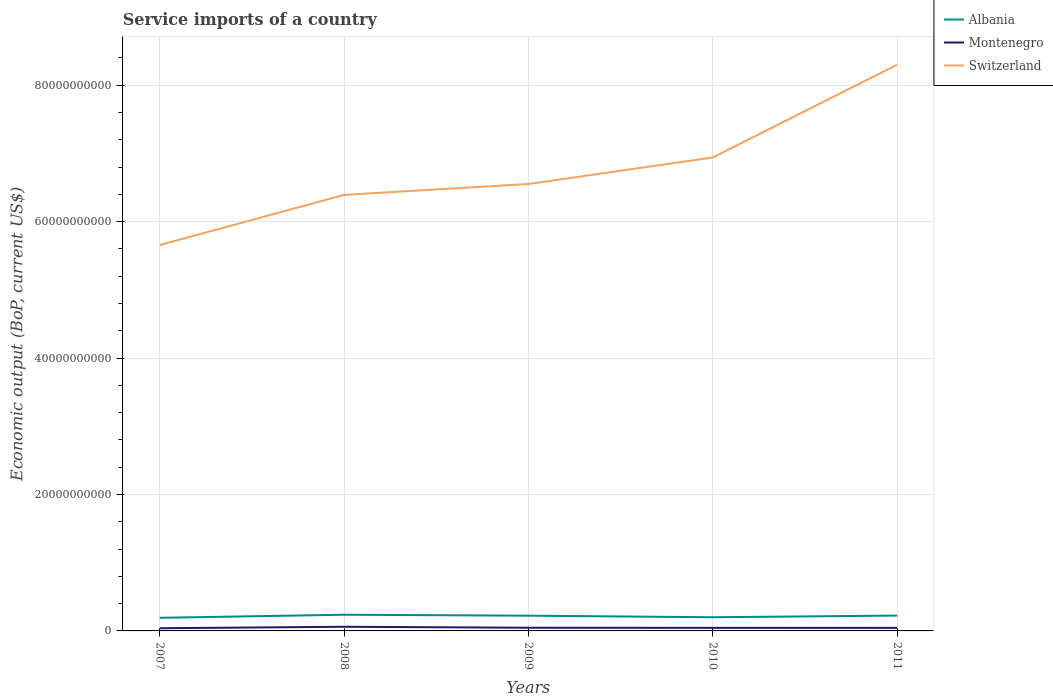Is the number of lines equal to the number of legend labels?
Make the answer very short. Yes. Across all years, what is the maximum service imports in Switzerland?
Your response must be concise. 5.66e+1. In which year was the service imports in Switzerland maximum?
Provide a short and direct response. 2007. What is the total service imports in Albania in the graph?
Keep it short and to the point. 2.26e+08. What is the difference between the highest and the second highest service imports in Albania?
Your answer should be compact. 4.48e+08. Is the service imports in Montenegro strictly greater than the service imports in Switzerland over the years?
Give a very brief answer. Yes. How many lines are there?
Ensure brevity in your answer.  3. What is the difference between two consecutive major ticks on the Y-axis?
Provide a short and direct response. 2.00e+1. Does the graph contain any zero values?
Provide a succinct answer. No. Where does the legend appear in the graph?
Make the answer very short. Top right. How many legend labels are there?
Make the answer very short. 3. What is the title of the graph?
Ensure brevity in your answer.  Service imports of a country. Does "Azerbaijan" appear as one of the legend labels in the graph?
Provide a short and direct response. No. What is the label or title of the X-axis?
Your response must be concise. Years. What is the label or title of the Y-axis?
Provide a short and direct response. Economic output (BoP, current US$). What is the Economic output (BoP, current US$) in Albania in 2007?
Your answer should be very brief. 1.92e+09. What is the Economic output (BoP, current US$) of Montenegro in 2007?
Ensure brevity in your answer.  3.94e+08. What is the Economic output (BoP, current US$) of Switzerland in 2007?
Provide a succinct answer. 5.66e+1. What is the Economic output (BoP, current US$) in Albania in 2008?
Your answer should be compact. 2.37e+09. What is the Economic output (BoP, current US$) in Montenegro in 2008?
Offer a very short reply. 6.09e+08. What is the Economic output (BoP, current US$) of Switzerland in 2008?
Provide a succinct answer. 6.39e+1. What is the Economic output (BoP, current US$) of Albania in 2009?
Keep it short and to the point. 2.23e+09. What is the Economic output (BoP, current US$) of Montenegro in 2009?
Make the answer very short. 4.67e+08. What is the Economic output (BoP, current US$) of Switzerland in 2009?
Your answer should be compact. 6.55e+1. What is the Economic output (BoP, current US$) in Albania in 2010?
Your response must be concise. 2.01e+09. What is the Economic output (BoP, current US$) in Montenegro in 2010?
Offer a very short reply. 4.51e+08. What is the Economic output (BoP, current US$) in Switzerland in 2010?
Ensure brevity in your answer.  6.94e+1. What is the Economic output (BoP, current US$) of Albania in 2011?
Provide a succinct answer. 2.25e+09. What is the Economic output (BoP, current US$) of Montenegro in 2011?
Offer a terse response. 4.48e+08. What is the Economic output (BoP, current US$) in Switzerland in 2011?
Give a very brief answer. 8.30e+1. Across all years, what is the maximum Economic output (BoP, current US$) in Albania?
Your response must be concise. 2.37e+09. Across all years, what is the maximum Economic output (BoP, current US$) of Montenegro?
Provide a succinct answer. 6.09e+08. Across all years, what is the maximum Economic output (BoP, current US$) in Switzerland?
Keep it short and to the point. 8.30e+1. Across all years, what is the minimum Economic output (BoP, current US$) of Albania?
Your response must be concise. 1.92e+09. Across all years, what is the minimum Economic output (BoP, current US$) of Montenegro?
Offer a very short reply. 3.94e+08. Across all years, what is the minimum Economic output (BoP, current US$) in Switzerland?
Your answer should be compact. 5.66e+1. What is the total Economic output (BoP, current US$) of Albania in the graph?
Give a very brief answer. 1.08e+1. What is the total Economic output (BoP, current US$) in Montenegro in the graph?
Keep it short and to the point. 2.37e+09. What is the total Economic output (BoP, current US$) of Switzerland in the graph?
Your answer should be very brief. 3.38e+11. What is the difference between the Economic output (BoP, current US$) of Albania in 2007 and that in 2008?
Provide a succinct answer. -4.48e+08. What is the difference between the Economic output (BoP, current US$) of Montenegro in 2007 and that in 2008?
Your answer should be very brief. -2.15e+08. What is the difference between the Economic output (BoP, current US$) in Switzerland in 2007 and that in 2008?
Offer a terse response. -7.36e+09. What is the difference between the Economic output (BoP, current US$) in Albania in 2007 and that in 2009?
Your response must be concise. -3.08e+08. What is the difference between the Economic output (BoP, current US$) in Montenegro in 2007 and that in 2009?
Your answer should be very brief. -7.32e+07. What is the difference between the Economic output (BoP, current US$) of Switzerland in 2007 and that in 2009?
Your answer should be very brief. -8.95e+09. What is the difference between the Economic output (BoP, current US$) of Albania in 2007 and that in 2010?
Offer a very short reply. -8.23e+07. What is the difference between the Economic output (BoP, current US$) of Montenegro in 2007 and that in 2010?
Your response must be concise. -5.69e+07. What is the difference between the Economic output (BoP, current US$) of Switzerland in 2007 and that in 2010?
Your answer should be very brief. -1.28e+1. What is the difference between the Economic output (BoP, current US$) of Albania in 2007 and that in 2011?
Give a very brief answer. -3.24e+08. What is the difference between the Economic output (BoP, current US$) of Montenegro in 2007 and that in 2011?
Offer a very short reply. -5.38e+07. What is the difference between the Economic output (BoP, current US$) in Switzerland in 2007 and that in 2011?
Make the answer very short. -2.64e+1. What is the difference between the Economic output (BoP, current US$) of Albania in 2008 and that in 2009?
Give a very brief answer. 1.40e+08. What is the difference between the Economic output (BoP, current US$) of Montenegro in 2008 and that in 2009?
Keep it short and to the point. 1.42e+08. What is the difference between the Economic output (BoP, current US$) of Switzerland in 2008 and that in 2009?
Your answer should be very brief. -1.59e+09. What is the difference between the Economic output (BoP, current US$) of Albania in 2008 and that in 2010?
Your answer should be compact. 3.65e+08. What is the difference between the Economic output (BoP, current US$) of Montenegro in 2008 and that in 2010?
Your answer should be very brief. 1.58e+08. What is the difference between the Economic output (BoP, current US$) in Switzerland in 2008 and that in 2010?
Keep it short and to the point. -5.48e+09. What is the difference between the Economic output (BoP, current US$) of Albania in 2008 and that in 2011?
Your answer should be compact. 1.24e+08. What is the difference between the Economic output (BoP, current US$) of Montenegro in 2008 and that in 2011?
Offer a terse response. 1.61e+08. What is the difference between the Economic output (BoP, current US$) of Switzerland in 2008 and that in 2011?
Your answer should be compact. -1.91e+1. What is the difference between the Economic output (BoP, current US$) of Albania in 2009 and that in 2010?
Your answer should be compact. 2.26e+08. What is the difference between the Economic output (BoP, current US$) of Montenegro in 2009 and that in 2010?
Ensure brevity in your answer.  1.63e+07. What is the difference between the Economic output (BoP, current US$) of Switzerland in 2009 and that in 2010?
Offer a very short reply. -3.89e+09. What is the difference between the Economic output (BoP, current US$) in Albania in 2009 and that in 2011?
Your response must be concise. -1.58e+07. What is the difference between the Economic output (BoP, current US$) of Montenegro in 2009 and that in 2011?
Offer a very short reply. 1.94e+07. What is the difference between the Economic output (BoP, current US$) in Switzerland in 2009 and that in 2011?
Your answer should be compact. -1.75e+1. What is the difference between the Economic output (BoP, current US$) of Albania in 2010 and that in 2011?
Keep it short and to the point. -2.42e+08. What is the difference between the Economic output (BoP, current US$) of Montenegro in 2010 and that in 2011?
Provide a short and direct response. 3.09e+06. What is the difference between the Economic output (BoP, current US$) in Switzerland in 2010 and that in 2011?
Ensure brevity in your answer.  -1.36e+1. What is the difference between the Economic output (BoP, current US$) of Albania in 2007 and the Economic output (BoP, current US$) of Montenegro in 2008?
Give a very brief answer. 1.32e+09. What is the difference between the Economic output (BoP, current US$) of Albania in 2007 and the Economic output (BoP, current US$) of Switzerland in 2008?
Offer a terse response. -6.20e+1. What is the difference between the Economic output (BoP, current US$) of Montenegro in 2007 and the Economic output (BoP, current US$) of Switzerland in 2008?
Keep it short and to the point. -6.35e+1. What is the difference between the Economic output (BoP, current US$) in Albania in 2007 and the Economic output (BoP, current US$) in Montenegro in 2009?
Offer a very short reply. 1.46e+09. What is the difference between the Economic output (BoP, current US$) in Albania in 2007 and the Economic output (BoP, current US$) in Switzerland in 2009?
Give a very brief answer. -6.36e+1. What is the difference between the Economic output (BoP, current US$) of Montenegro in 2007 and the Economic output (BoP, current US$) of Switzerland in 2009?
Ensure brevity in your answer.  -6.51e+1. What is the difference between the Economic output (BoP, current US$) in Albania in 2007 and the Economic output (BoP, current US$) in Montenegro in 2010?
Offer a terse response. 1.47e+09. What is the difference between the Economic output (BoP, current US$) of Albania in 2007 and the Economic output (BoP, current US$) of Switzerland in 2010?
Your answer should be very brief. -6.75e+1. What is the difference between the Economic output (BoP, current US$) of Montenegro in 2007 and the Economic output (BoP, current US$) of Switzerland in 2010?
Offer a terse response. -6.90e+1. What is the difference between the Economic output (BoP, current US$) in Albania in 2007 and the Economic output (BoP, current US$) in Montenegro in 2011?
Keep it short and to the point. 1.48e+09. What is the difference between the Economic output (BoP, current US$) in Albania in 2007 and the Economic output (BoP, current US$) in Switzerland in 2011?
Provide a short and direct response. -8.11e+1. What is the difference between the Economic output (BoP, current US$) in Montenegro in 2007 and the Economic output (BoP, current US$) in Switzerland in 2011?
Your answer should be very brief. -8.26e+1. What is the difference between the Economic output (BoP, current US$) of Albania in 2008 and the Economic output (BoP, current US$) of Montenegro in 2009?
Provide a short and direct response. 1.91e+09. What is the difference between the Economic output (BoP, current US$) of Albania in 2008 and the Economic output (BoP, current US$) of Switzerland in 2009?
Provide a succinct answer. -6.31e+1. What is the difference between the Economic output (BoP, current US$) of Montenegro in 2008 and the Economic output (BoP, current US$) of Switzerland in 2009?
Keep it short and to the point. -6.49e+1. What is the difference between the Economic output (BoP, current US$) in Albania in 2008 and the Economic output (BoP, current US$) in Montenegro in 2010?
Make the answer very short. 1.92e+09. What is the difference between the Economic output (BoP, current US$) in Albania in 2008 and the Economic output (BoP, current US$) in Switzerland in 2010?
Your answer should be compact. -6.70e+1. What is the difference between the Economic output (BoP, current US$) in Montenegro in 2008 and the Economic output (BoP, current US$) in Switzerland in 2010?
Offer a very short reply. -6.88e+1. What is the difference between the Economic output (BoP, current US$) in Albania in 2008 and the Economic output (BoP, current US$) in Montenegro in 2011?
Offer a very short reply. 1.92e+09. What is the difference between the Economic output (BoP, current US$) of Albania in 2008 and the Economic output (BoP, current US$) of Switzerland in 2011?
Give a very brief answer. -8.06e+1. What is the difference between the Economic output (BoP, current US$) in Montenegro in 2008 and the Economic output (BoP, current US$) in Switzerland in 2011?
Your answer should be very brief. -8.24e+1. What is the difference between the Economic output (BoP, current US$) of Albania in 2009 and the Economic output (BoP, current US$) of Montenegro in 2010?
Your answer should be very brief. 1.78e+09. What is the difference between the Economic output (BoP, current US$) of Albania in 2009 and the Economic output (BoP, current US$) of Switzerland in 2010?
Your response must be concise. -6.72e+1. What is the difference between the Economic output (BoP, current US$) in Montenegro in 2009 and the Economic output (BoP, current US$) in Switzerland in 2010?
Ensure brevity in your answer.  -6.89e+1. What is the difference between the Economic output (BoP, current US$) in Albania in 2009 and the Economic output (BoP, current US$) in Montenegro in 2011?
Your answer should be compact. 1.78e+09. What is the difference between the Economic output (BoP, current US$) in Albania in 2009 and the Economic output (BoP, current US$) in Switzerland in 2011?
Ensure brevity in your answer.  -8.08e+1. What is the difference between the Economic output (BoP, current US$) in Montenegro in 2009 and the Economic output (BoP, current US$) in Switzerland in 2011?
Provide a short and direct response. -8.25e+1. What is the difference between the Economic output (BoP, current US$) of Albania in 2010 and the Economic output (BoP, current US$) of Montenegro in 2011?
Make the answer very short. 1.56e+09. What is the difference between the Economic output (BoP, current US$) in Albania in 2010 and the Economic output (BoP, current US$) in Switzerland in 2011?
Your response must be concise. -8.10e+1. What is the difference between the Economic output (BoP, current US$) in Montenegro in 2010 and the Economic output (BoP, current US$) in Switzerland in 2011?
Ensure brevity in your answer.  -8.26e+1. What is the average Economic output (BoP, current US$) of Albania per year?
Provide a short and direct response. 2.16e+09. What is the average Economic output (BoP, current US$) of Montenegro per year?
Provide a succinct answer. 4.74e+08. What is the average Economic output (BoP, current US$) of Switzerland per year?
Make the answer very short. 6.77e+1. In the year 2007, what is the difference between the Economic output (BoP, current US$) of Albania and Economic output (BoP, current US$) of Montenegro?
Provide a short and direct response. 1.53e+09. In the year 2007, what is the difference between the Economic output (BoP, current US$) of Albania and Economic output (BoP, current US$) of Switzerland?
Your response must be concise. -5.46e+1. In the year 2007, what is the difference between the Economic output (BoP, current US$) in Montenegro and Economic output (BoP, current US$) in Switzerland?
Your response must be concise. -5.62e+1. In the year 2008, what is the difference between the Economic output (BoP, current US$) of Albania and Economic output (BoP, current US$) of Montenegro?
Offer a very short reply. 1.76e+09. In the year 2008, what is the difference between the Economic output (BoP, current US$) of Albania and Economic output (BoP, current US$) of Switzerland?
Offer a very short reply. -6.16e+1. In the year 2008, what is the difference between the Economic output (BoP, current US$) of Montenegro and Economic output (BoP, current US$) of Switzerland?
Offer a terse response. -6.33e+1. In the year 2009, what is the difference between the Economic output (BoP, current US$) in Albania and Economic output (BoP, current US$) in Montenegro?
Offer a very short reply. 1.77e+09. In the year 2009, what is the difference between the Economic output (BoP, current US$) in Albania and Economic output (BoP, current US$) in Switzerland?
Give a very brief answer. -6.33e+1. In the year 2009, what is the difference between the Economic output (BoP, current US$) in Montenegro and Economic output (BoP, current US$) in Switzerland?
Offer a very short reply. -6.51e+1. In the year 2010, what is the difference between the Economic output (BoP, current US$) of Albania and Economic output (BoP, current US$) of Montenegro?
Your response must be concise. 1.56e+09. In the year 2010, what is the difference between the Economic output (BoP, current US$) of Albania and Economic output (BoP, current US$) of Switzerland?
Provide a succinct answer. -6.74e+1. In the year 2010, what is the difference between the Economic output (BoP, current US$) of Montenegro and Economic output (BoP, current US$) of Switzerland?
Make the answer very short. -6.90e+1. In the year 2011, what is the difference between the Economic output (BoP, current US$) of Albania and Economic output (BoP, current US$) of Montenegro?
Make the answer very short. 1.80e+09. In the year 2011, what is the difference between the Economic output (BoP, current US$) of Albania and Economic output (BoP, current US$) of Switzerland?
Offer a terse response. -8.08e+1. In the year 2011, what is the difference between the Economic output (BoP, current US$) of Montenegro and Economic output (BoP, current US$) of Switzerland?
Your answer should be compact. -8.26e+1. What is the ratio of the Economic output (BoP, current US$) in Albania in 2007 to that in 2008?
Give a very brief answer. 0.81. What is the ratio of the Economic output (BoP, current US$) in Montenegro in 2007 to that in 2008?
Offer a terse response. 0.65. What is the ratio of the Economic output (BoP, current US$) in Switzerland in 2007 to that in 2008?
Keep it short and to the point. 0.88. What is the ratio of the Economic output (BoP, current US$) of Albania in 2007 to that in 2009?
Keep it short and to the point. 0.86. What is the ratio of the Economic output (BoP, current US$) in Montenegro in 2007 to that in 2009?
Make the answer very short. 0.84. What is the ratio of the Economic output (BoP, current US$) of Switzerland in 2007 to that in 2009?
Your answer should be compact. 0.86. What is the ratio of the Economic output (BoP, current US$) of Montenegro in 2007 to that in 2010?
Provide a short and direct response. 0.87. What is the ratio of the Economic output (BoP, current US$) in Switzerland in 2007 to that in 2010?
Offer a very short reply. 0.81. What is the ratio of the Economic output (BoP, current US$) in Albania in 2007 to that in 2011?
Your answer should be compact. 0.86. What is the ratio of the Economic output (BoP, current US$) in Montenegro in 2007 to that in 2011?
Keep it short and to the point. 0.88. What is the ratio of the Economic output (BoP, current US$) of Switzerland in 2007 to that in 2011?
Your answer should be compact. 0.68. What is the ratio of the Economic output (BoP, current US$) in Montenegro in 2008 to that in 2009?
Your answer should be compact. 1.3. What is the ratio of the Economic output (BoP, current US$) in Switzerland in 2008 to that in 2009?
Offer a very short reply. 0.98. What is the ratio of the Economic output (BoP, current US$) in Albania in 2008 to that in 2010?
Keep it short and to the point. 1.18. What is the ratio of the Economic output (BoP, current US$) of Montenegro in 2008 to that in 2010?
Give a very brief answer. 1.35. What is the ratio of the Economic output (BoP, current US$) of Switzerland in 2008 to that in 2010?
Give a very brief answer. 0.92. What is the ratio of the Economic output (BoP, current US$) in Albania in 2008 to that in 2011?
Your answer should be very brief. 1.06. What is the ratio of the Economic output (BoP, current US$) of Montenegro in 2008 to that in 2011?
Provide a short and direct response. 1.36. What is the ratio of the Economic output (BoP, current US$) of Switzerland in 2008 to that in 2011?
Offer a very short reply. 0.77. What is the ratio of the Economic output (BoP, current US$) of Albania in 2009 to that in 2010?
Provide a succinct answer. 1.11. What is the ratio of the Economic output (BoP, current US$) in Montenegro in 2009 to that in 2010?
Keep it short and to the point. 1.04. What is the ratio of the Economic output (BoP, current US$) in Switzerland in 2009 to that in 2010?
Ensure brevity in your answer.  0.94. What is the ratio of the Economic output (BoP, current US$) in Albania in 2009 to that in 2011?
Make the answer very short. 0.99. What is the ratio of the Economic output (BoP, current US$) in Montenegro in 2009 to that in 2011?
Your response must be concise. 1.04. What is the ratio of the Economic output (BoP, current US$) in Switzerland in 2009 to that in 2011?
Ensure brevity in your answer.  0.79. What is the ratio of the Economic output (BoP, current US$) in Albania in 2010 to that in 2011?
Your response must be concise. 0.89. What is the ratio of the Economic output (BoP, current US$) of Montenegro in 2010 to that in 2011?
Keep it short and to the point. 1.01. What is the ratio of the Economic output (BoP, current US$) in Switzerland in 2010 to that in 2011?
Offer a very short reply. 0.84. What is the difference between the highest and the second highest Economic output (BoP, current US$) of Albania?
Provide a short and direct response. 1.24e+08. What is the difference between the highest and the second highest Economic output (BoP, current US$) in Montenegro?
Offer a very short reply. 1.42e+08. What is the difference between the highest and the second highest Economic output (BoP, current US$) in Switzerland?
Ensure brevity in your answer.  1.36e+1. What is the difference between the highest and the lowest Economic output (BoP, current US$) in Albania?
Your response must be concise. 4.48e+08. What is the difference between the highest and the lowest Economic output (BoP, current US$) in Montenegro?
Offer a terse response. 2.15e+08. What is the difference between the highest and the lowest Economic output (BoP, current US$) in Switzerland?
Ensure brevity in your answer.  2.64e+1. 